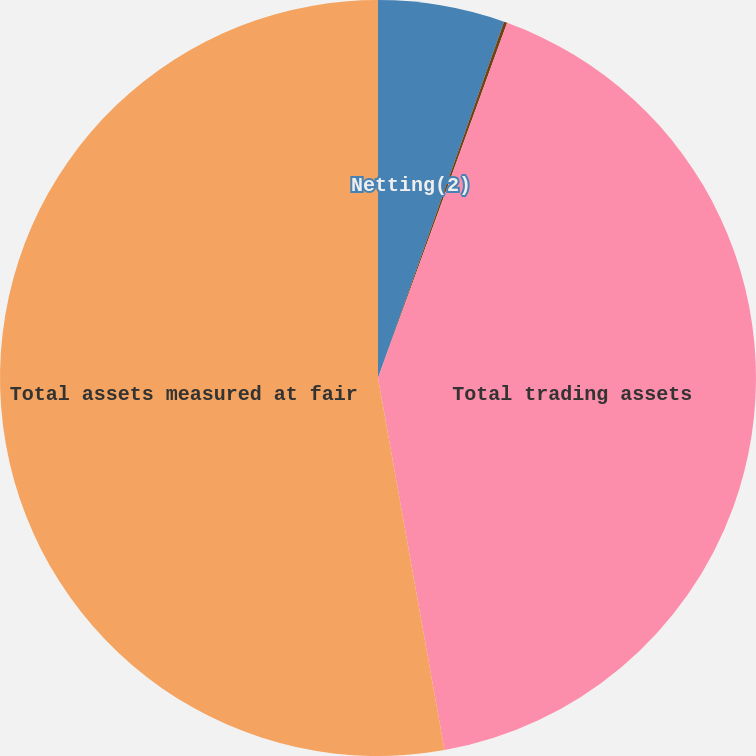Convert chart. <chart><loc_0><loc_0><loc_500><loc_500><pie_chart><fcel>Netting(2)<fcel>Total derivative and other<fcel>Total trading assets<fcel>Total assets measured at fair<nl><fcel>5.41%<fcel>0.14%<fcel>41.63%<fcel>52.81%<nl></chart> 